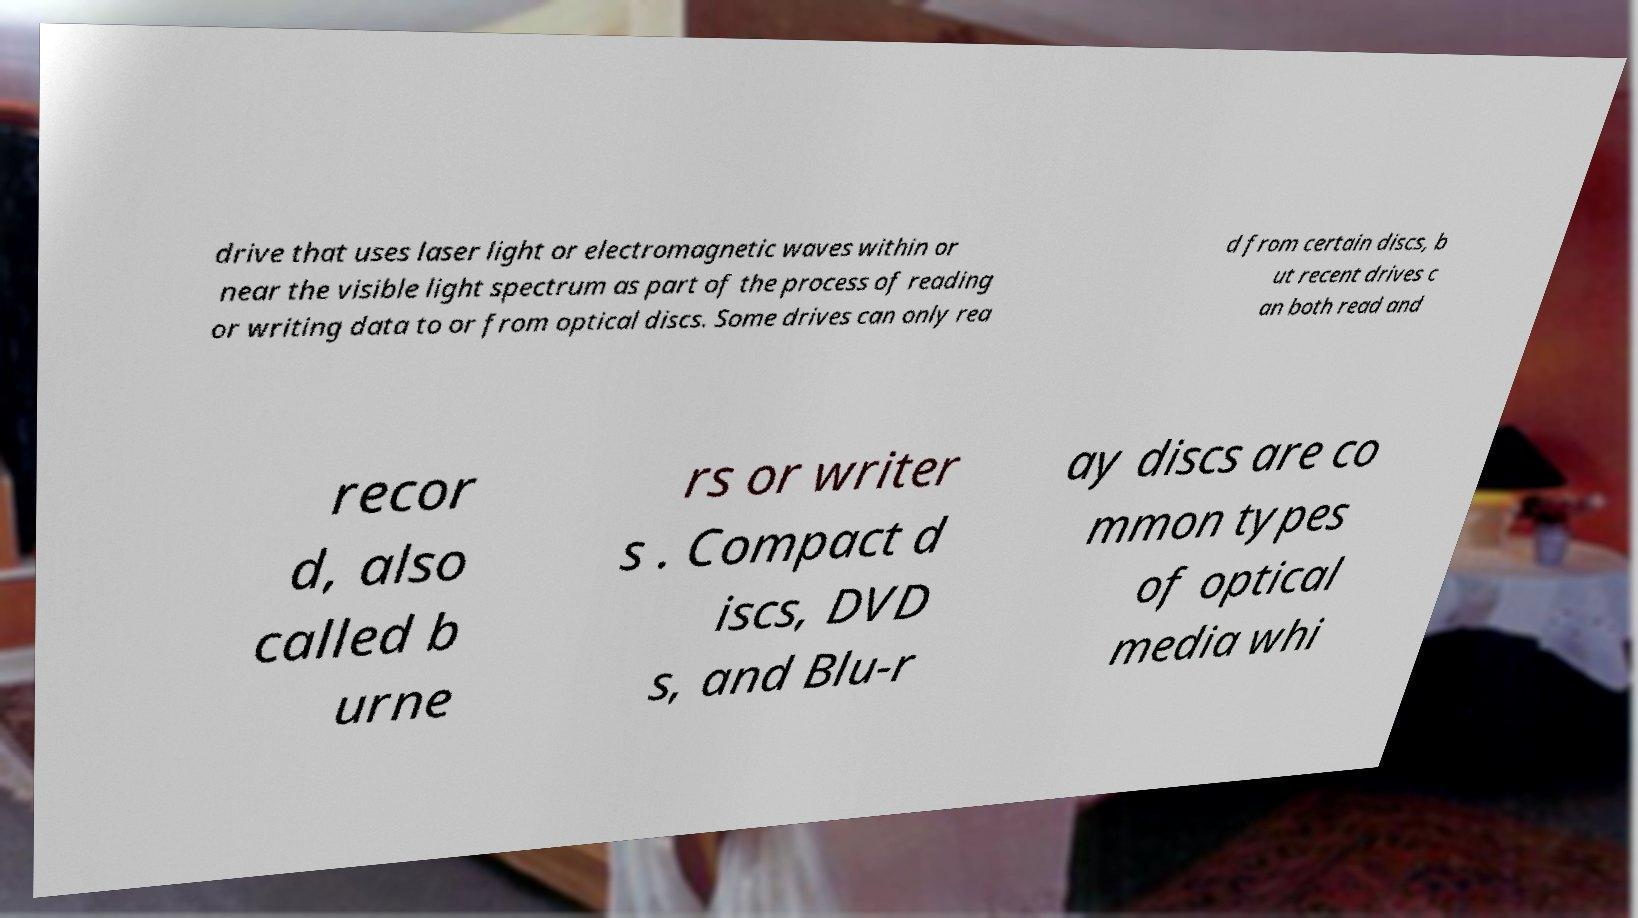Could you extract and type out the text from this image? drive that uses laser light or electromagnetic waves within or near the visible light spectrum as part of the process of reading or writing data to or from optical discs. Some drives can only rea d from certain discs, b ut recent drives c an both read and recor d, also called b urne rs or writer s . Compact d iscs, DVD s, and Blu-r ay discs are co mmon types of optical media whi 